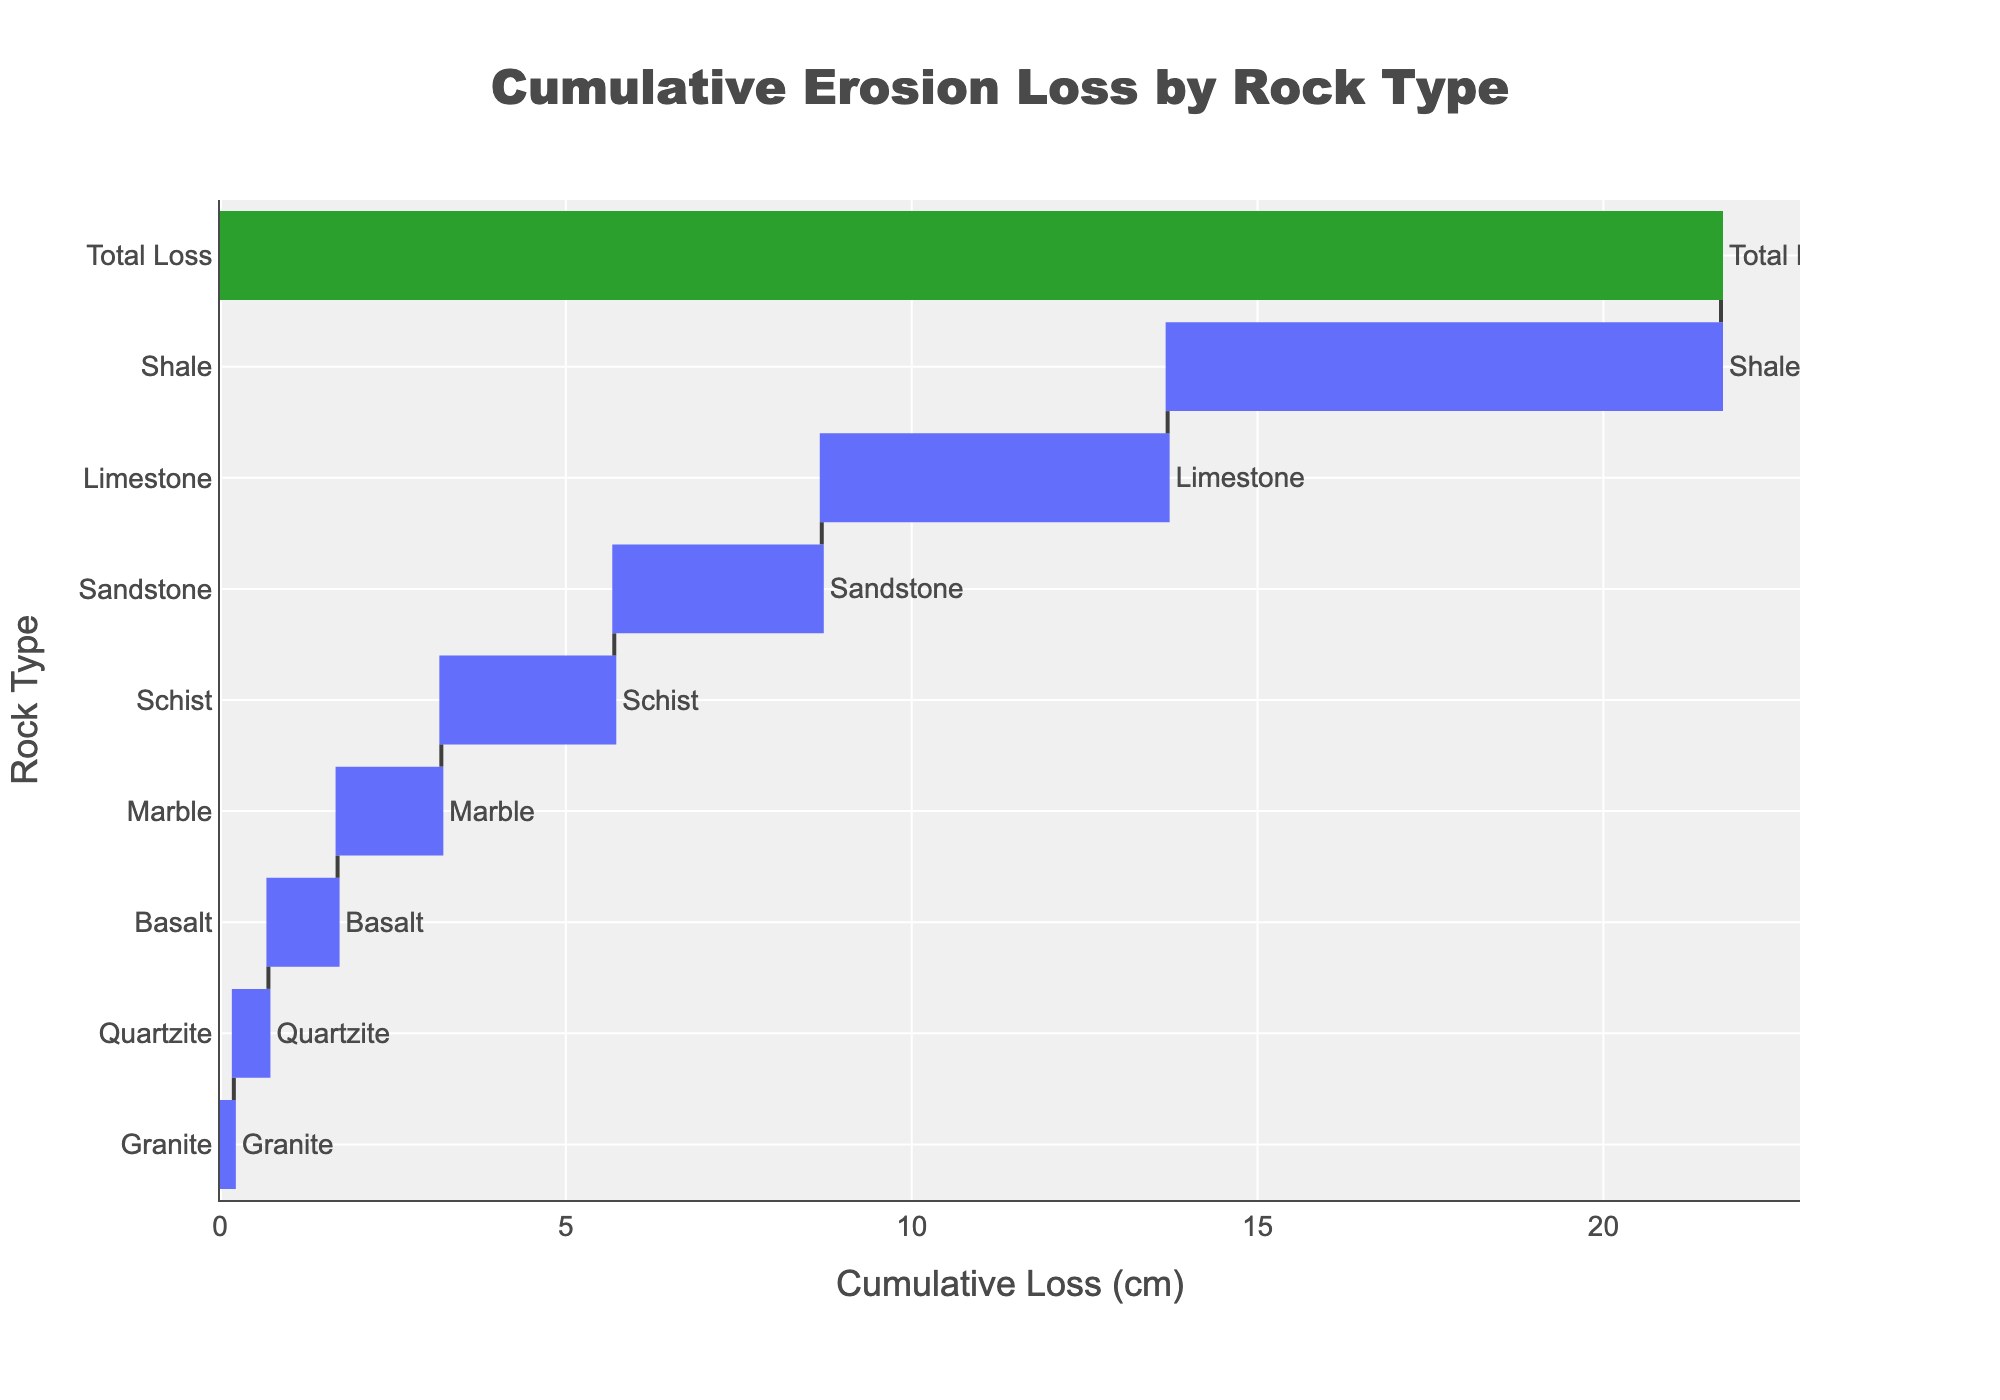How many rock types are shown in the chart? Count the distinct rock types listed on the y-axis. There are 8 individual rock types plus the "Total Loss" making 9 items in total.
Answer: 9 What is the title of the chart? The title is usually displayed at the top of the chart. In this case, the title is provided in the data.
Answer: Cumulative Erosion Loss by Rock Type Which rock type has the highest cumulative erosion loss? Locate the bar with the largest length on the x-axis, which corresponds to the y-axis label. The rock type is Shale with 8.0 cm.
Answer: Shale What is the cumulative loss for Granite? Identify the bar labeled "Granite" on the y-axis and read the value on the x-axis. The value is 0.2 cm.
Answer: 0.2 cm What's the difference in cumulative loss between Shale and Quartzite? Find the cumulative loss values for both Shale (8.0 cm) and Quartzite (0.5 cm), then subtract the smaller value from the larger one: 8.0 - 0.5 = 7.5 cm.
Answer: 7.5 cm How does the cumulative loss of Basalt compare to Marble? Find the cumulative loss values for Basalt (1.0 cm) and Marble (1.5 cm) from the chart and compare them. Marble has a higher cumulative loss than Basalt by 0.5 cm.
Answer: Marble > Basalt What is the combined cumulative loss of Limestone and Sandstone? Sum the cumulative loss values of Limestone (5.0 cm) and Sandstone (3.0 cm) found on the x-axis: 5.0 + 3.0 = 8.0 cm.
Answer: 8.0 cm What is the cumulative loss shown by the "Total Loss" bar? “Total Loss” is a special bar usually marked with a different color. In this case, it represents a cumulative loss of 21.7 cm.
Answer: 21.7 cm Why is the color of the "Total Loss" bar different from other bars? In waterfall charts, the "Total Loss" bar is often colored differently to distinguish it from individual contributing factors. It typically summarizes the overall result.
Answer: To distinguish the summary value Which rock types have a cumulative loss equal to or less than 1.0 cm? Identify the bars whose lengths on the x-axis are equal to or less than 1.0 cm. They are Granite (0.2 cm), Basalt (1.0 cm), and Quartzite (0.5 cm).
Answer: Granite, Basalt, Quartzite 